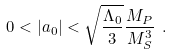Convert formula to latex. <formula><loc_0><loc_0><loc_500><loc_500>0 < | a _ { 0 } | < \sqrt { \frac { \Lambda _ { 0 } } { 3 } } \frac { M _ { P } } { M _ { S } ^ { 3 } } \ .</formula> 